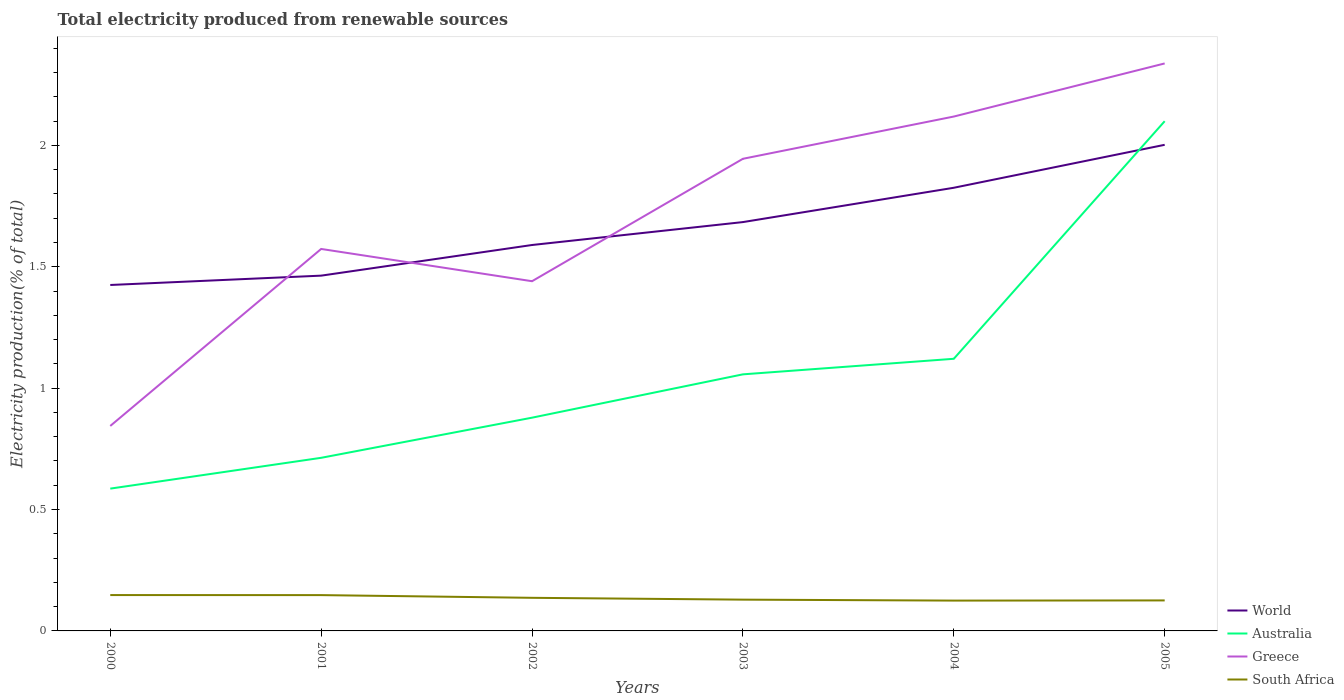Is the number of lines equal to the number of legend labels?
Provide a succinct answer. Yes. Across all years, what is the maximum total electricity produced in South Africa?
Ensure brevity in your answer.  0.12. What is the total total electricity produced in South Africa in the graph?
Make the answer very short. 0.01. What is the difference between the highest and the second highest total electricity produced in Australia?
Make the answer very short. 1.51. How many lines are there?
Give a very brief answer. 4. What is the difference between two consecutive major ticks on the Y-axis?
Keep it short and to the point. 0.5. Are the values on the major ticks of Y-axis written in scientific E-notation?
Your answer should be very brief. No. Does the graph contain any zero values?
Ensure brevity in your answer.  No. Where does the legend appear in the graph?
Keep it short and to the point. Bottom right. How many legend labels are there?
Make the answer very short. 4. What is the title of the graph?
Ensure brevity in your answer.  Total electricity produced from renewable sources. What is the label or title of the X-axis?
Offer a very short reply. Years. What is the label or title of the Y-axis?
Ensure brevity in your answer.  Electricity production(% of total). What is the Electricity production(% of total) in World in 2000?
Ensure brevity in your answer.  1.42. What is the Electricity production(% of total) in Australia in 2000?
Ensure brevity in your answer.  0.59. What is the Electricity production(% of total) in Greece in 2000?
Offer a very short reply. 0.84. What is the Electricity production(% of total) in South Africa in 2000?
Provide a short and direct response. 0.15. What is the Electricity production(% of total) in World in 2001?
Give a very brief answer. 1.46. What is the Electricity production(% of total) in Australia in 2001?
Offer a terse response. 0.71. What is the Electricity production(% of total) of Greece in 2001?
Offer a terse response. 1.57. What is the Electricity production(% of total) in South Africa in 2001?
Provide a succinct answer. 0.15. What is the Electricity production(% of total) in World in 2002?
Give a very brief answer. 1.59. What is the Electricity production(% of total) in Australia in 2002?
Offer a very short reply. 0.88. What is the Electricity production(% of total) of Greece in 2002?
Provide a short and direct response. 1.44. What is the Electricity production(% of total) in South Africa in 2002?
Provide a short and direct response. 0.14. What is the Electricity production(% of total) in World in 2003?
Your answer should be compact. 1.68. What is the Electricity production(% of total) of Australia in 2003?
Give a very brief answer. 1.06. What is the Electricity production(% of total) of Greece in 2003?
Keep it short and to the point. 1.94. What is the Electricity production(% of total) in South Africa in 2003?
Provide a succinct answer. 0.13. What is the Electricity production(% of total) in World in 2004?
Offer a very short reply. 1.83. What is the Electricity production(% of total) in Australia in 2004?
Your answer should be compact. 1.12. What is the Electricity production(% of total) in Greece in 2004?
Offer a terse response. 2.12. What is the Electricity production(% of total) in South Africa in 2004?
Make the answer very short. 0.12. What is the Electricity production(% of total) in World in 2005?
Your answer should be compact. 2. What is the Electricity production(% of total) of Australia in 2005?
Provide a succinct answer. 2.1. What is the Electricity production(% of total) of Greece in 2005?
Give a very brief answer. 2.34. What is the Electricity production(% of total) in South Africa in 2005?
Your response must be concise. 0.13. Across all years, what is the maximum Electricity production(% of total) of World?
Ensure brevity in your answer.  2. Across all years, what is the maximum Electricity production(% of total) in Australia?
Provide a short and direct response. 2.1. Across all years, what is the maximum Electricity production(% of total) of Greece?
Keep it short and to the point. 2.34. Across all years, what is the maximum Electricity production(% of total) in South Africa?
Offer a terse response. 0.15. Across all years, what is the minimum Electricity production(% of total) in World?
Provide a succinct answer. 1.42. Across all years, what is the minimum Electricity production(% of total) of Australia?
Ensure brevity in your answer.  0.59. Across all years, what is the minimum Electricity production(% of total) of Greece?
Your response must be concise. 0.84. Across all years, what is the minimum Electricity production(% of total) of South Africa?
Give a very brief answer. 0.12. What is the total Electricity production(% of total) of World in the graph?
Make the answer very short. 9.99. What is the total Electricity production(% of total) in Australia in the graph?
Offer a very short reply. 6.45. What is the total Electricity production(% of total) in Greece in the graph?
Your response must be concise. 10.26. What is the total Electricity production(% of total) in South Africa in the graph?
Give a very brief answer. 0.81. What is the difference between the Electricity production(% of total) of World in 2000 and that in 2001?
Your response must be concise. -0.04. What is the difference between the Electricity production(% of total) of Australia in 2000 and that in 2001?
Your answer should be very brief. -0.13. What is the difference between the Electricity production(% of total) in Greece in 2000 and that in 2001?
Offer a very short reply. -0.73. What is the difference between the Electricity production(% of total) of South Africa in 2000 and that in 2001?
Offer a very short reply. 0. What is the difference between the Electricity production(% of total) of World in 2000 and that in 2002?
Offer a terse response. -0.16. What is the difference between the Electricity production(% of total) of Australia in 2000 and that in 2002?
Provide a short and direct response. -0.29. What is the difference between the Electricity production(% of total) in Greece in 2000 and that in 2002?
Your answer should be very brief. -0.6. What is the difference between the Electricity production(% of total) in South Africa in 2000 and that in 2002?
Your answer should be very brief. 0.01. What is the difference between the Electricity production(% of total) in World in 2000 and that in 2003?
Offer a terse response. -0.26. What is the difference between the Electricity production(% of total) in Australia in 2000 and that in 2003?
Give a very brief answer. -0.47. What is the difference between the Electricity production(% of total) of Greece in 2000 and that in 2003?
Provide a short and direct response. -1.1. What is the difference between the Electricity production(% of total) in South Africa in 2000 and that in 2003?
Offer a very short reply. 0.02. What is the difference between the Electricity production(% of total) of World in 2000 and that in 2004?
Ensure brevity in your answer.  -0.4. What is the difference between the Electricity production(% of total) of Australia in 2000 and that in 2004?
Keep it short and to the point. -0.53. What is the difference between the Electricity production(% of total) of Greece in 2000 and that in 2004?
Provide a succinct answer. -1.27. What is the difference between the Electricity production(% of total) in South Africa in 2000 and that in 2004?
Your response must be concise. 0.02. What is the difference between the Electricity production(% of total) in World in 2000 and that in 2005?
Offer a terse response. -0.58. What is the difference between the Electricity production(% of total) of Australia in 2000 and that in 2005?
Offer a very short reply. -1.51. What is the difference between the Electricity production(% of total) in Greece in 2000 and that in 2005?
Your answer should be very brief. -1.49. What is the difference between the Electricity production(% of total) of South Africa in 2000 and that in 2005?
Give a very brief answer. 0.02. What is the difference between the Electricity production(% of total) of World in 2001 and that in 2002?
Give a very brief answer. -0.13. What is the difference between the Electricity production(% of total) in Australia in 2001 and that in 2002?
Ensure brevity in your answer.  -0.17. What is the difference between the Electricity production(% of total) in Greece in 2001 and that in 2002?
Keep it short and to the point. 0.13. What is the difference between the Electricity production(% of total) in South Africa in 2001 and that in 2002?
Your answer should be compact. 0.01. What is the difference between the Electricity production(% of total) of World in 2001 and that in 2003?
Ensure brevity in your answer.  -0.22. What is the difference between the Electricity production(% of total) in Australia in 2001 and that in 2003?
Offer a terse response. -0.34. What is the difference between the Electricity production(% of total) in Greece in 2001 and that in 2003?
Your answer should be compact. -0.37. What is the difference between the Electricity production(% of total) in South Africa in 2001 and that in 2003?
Provide a succinct answer. 0.02. What is the difference between the Electricity production(% of total) in World in 2001 and that in 2004?
Your answer should be compact. -0.36. What is the difference between the Electricity production(% of total) of Australia in 2001 and that in 2004?
Your answer should be very brief. -0.41. What is the difference between the Electricity production(% of total) of Greece in 2001 and that in 2004?
Your response must be concise. -0.55. What is the difference between the Electricity production(% of total) in South Africa in 2001 and that in 2004?
Make the answer very short. 0.02. What is the difference between the Electricity production(% of total) of World in 2001 and that in 2005?
Provide a succinct answer. -0.54. What is the difference between the Electricity production(% of total) in Australia in 2001 and that in 2005?
Offer a terse response. -1.39. What is the difference between the Electricity production(% of total) of Greece in 2001 and that in 2005?
Your response must be concise. -0.76. What is the difference between the Electricity production(% of total) in South Africa in 2001 and that in 2005?
Your response must be concise. 0.02. What is the difference between the Electricity production(% of total) of World in 2002 and that in 2003?
Make the answer very short. -0.09. What is the difference between the Electricity production(% of total) in Australia in 2002 and that in 2003?
Offer a very short reply. -0.18. What is the difference between the Electricity production(% of total) of Greece in 2002 and that in 2003?
Make the answer very short. -0.5. What is the difference between the Electricity production(% of total) of South Africa in 2002 and that in 2003?
Give a very brief answer. 0.01. What is the difference between the Electricity production(% of total) of World in 2002 and that in 2004?
Your answer should be very brief. -0.24. What is the difference between the Electricity production(% of total) in Australia in 2002 and that in 2004?
Offer a terse response. -0.24. What is the difference between the Electricity production(% of total) of Greece in 2002 and that in 2004?
Offer a terse response. -0.68. What is the difference between the Electricity production(% of total) of South Africa in 2002 and that in 2004?
Your answer should be very brief. 0.01. What is the difference between the Electricity production(% of total) in World in 2002 and that in 2005?
Provide a succinct answer. -0.41. What is the difference between the Electricity production(% of total) of Australia in 2002 and that in 2005?
Provide a succinct answer. -1.22. What is the difference between the Electricity production(% of total) in Greece in 2002 and that in 2005?
Make the answer very short. -0.9. What is the difference between the Electricity production(% of total) of South Africa in 2002 and that in 2005?
Your answer should be very brief. 0.01. What is the difference between the Electricity production(% of total) in World in 2003 and that in 2004?
Your answer should be compact. -0.14. What is the difference between the Electricity production(% of total) of Australia in 2003 and that in 2004?
Offer a terse response. -0.06. What is the difference between the Electricity production(% of total) of Greece in 2003 and that in 2004?
Keep it short and to the point. -0.17. What is the difference between the Electricity production(% of total) in South Africa in 2003 and that in 2004?
Provide a short and direct response. 0. What is the difference between the Electricity production(% of total) of World in 2003 and that in 2005?
Offer a terse response. -0.32. What is the difference between the Electricity production(% of total) of Australia in 2003 and that in 2005?
Offer a terse response. -1.04. What is the difference between the Electricity production(% of total) of Greece in 2003 and that in 2005?
Ensure brevity in your answer.  -0.39. What is the difference between the Electricity production(% of total) in South Africa in 2003 and that in 2005?
Give a very brief answer. 0. What is the difference between the Electricity production(% of total) of World in 2004 and that in 2005?
Your answer should be compact. -0.18. What is the difference between the Electricity production(% of total) in Australia in 2004 and that in 2005?
Keep it short and to the point. -0.98. What is the difference between the Electricity production(% of total) in Greece in 2004 and that in 2005?
Ensure brevity in your answer.  -0.22. What is the difference between the Electricity production(% of total) in South Africa in 2004 and that in 2005?
Your answer should be very brief. -0. What is the difference between the Electricity production(% of total) of World in 2000 and the Electricity production(% of total) of Australia in 2001?
Offer a terse response. 0.71. What is the difference between the Electricity production(% of total) in World in 2000 and the Electricity production(% of total) in Greece in 2001?
Provide a succinct answer. -0.15. What is the difference between the Electricity production(% of total) of World in 2000 and the Electricity production(% of total) of South Africa in 2001?
Offer a very short reply. 1.28. What is the difference between the Electricity production(% of total) of Australia in 2000 and the Electricity production(% of total) of Greece in 2001?
Offer a terse response. -0.99. What is the difference between the Electricity production(% of total) in Australia in 2000 and the Electricity production(% of total) in South Africa in 2001?
Ensure brevity in your answer.  0.44. What is the difference between the Electricity production(% of total) in Greece in 2000 and the Electricity production(% of total) in South Africa in 2001?
Offer a very short reply. 0.7. What is the difference between the Electricity production(% of total) of World in 2000 and the Electricity production(% of total) of Australia in 2002?
Ensure brevity in your answer.  0.55. What is the difference between the Electricity production(% of total) in World in 2000 and the Electricity production(% of total) in Greece in 2002?
Keep it short and to the point. -0.02. What is the difference between the Electricity production(% of total) of World in 2000 and the Electricity production(% of total) of South Africa in 2002?
Keep it short and to the point. 1.29. What is the difference between the Electricity production(% of total) of Australia in 2000 and the Electricity production(% of total) of Greece in 2002?
Provide a succinct answer. -0.85. What is the difference between the Electricity production(% of total) of Australia in 2000 and the Electricity production(% of total) of South Africa in 2002?
Your response must be concise. 0.45. What is the difference between the Electricity production(% of total) in Greece in 2000 and the Electricity production(% of total) in South Africa in 2002?
Offer a terse response. 0.71. What is the difference between the Electricity production(% of total) of World in 2000 and the Electricity production(% of total) of Australia in 2003?
Keep it short and to the point. 0.37. What is the difference between the Electricity production(% of total) of World in 2000 and the Electricity production(% of total) of Greece in 2003?
Offer a terse response. -0.52. What is the difference between the Electricity production(% of total) in World in 2000 and the Electricity production(% of total) in South Africa in 2003?
Make the answer very short. 1.3. What is the difference between the Electricity production(% of total) in Australia in 2000 and the Electricity production(% of total) in Greece in 2003?
Make the answer very short. -1.36. What is the difference between the Electricity production(% of total) in Australia in 2000 and the Electricity production(% of total) in South Africa in 2003?
Keep it short and to the point. 0.46. What is the difference between the Electricity production(% of total) of Greece in 2000 and the Electricity production(% of total) of South Africa in 2003?
Provide a short and direct response. 0.72. What is the difference between the Electricity production(% of total) of World in 2000 and the Electricity production(% of total) of Australia in 2004?
Give a very brief answer. 0.3. What is the difference between the Electricity production(% of total) of World in 2000 and the Electricity production(% of total) of Greece in 2004?
Provide a short and direct response. -0.69. What is the difference between the Electricity production(% of total) in World in 2000 and the Electricity production(% of total) in South Africa in 2004?
Make the answer very short. 1.3. What is the difference between the Electricity production(% of total) of Australia in 2000 and the Electricity production(% of total) of Greece in 2004?
Provide a short and direct response. -1.53. What is the difference between the Electricity production(% of total) of Australia in 2000 and the Electricity production(% of total) of South Africa in 2004?
Give a very brief answer. 0.46. What is the difference between the Electricity production(% of total) in Greece in 2000 and the Electricity production(% of total) in South Africa in 2004?
Offer a very short reply. 0.72. What is the difference between the Electricity production(% of total) in World in 2000 and the Electricity production(% of total) in Australia in 2005?
Provide a succinct answer. -0.67. What is the difference between the Electricity production(% of total) of World in 2000 and the Electricity production(% of total) of Greece in 2005?
Keep it short and to the point. -0.91. What is the difference between the Electricity production(% of total) in World in 2000 and the Electricity production(% of total) in South Africa in 2005?
Offer a terse response. 1.3. What is the difference between the Electricity production(% of total) of Australia in 2000 and the Electricity production(% of total) of Greece in 2005?
Keep it short and to the point. -1.75. What is the difference between the Electricity production(% of total) in Australia in 2000 and the Electricity production(% of total) in South Africa in 2005?
Your answer should be very brief. 0.46. What is the difference between the Electricity production(% of total) of Greece in 2000 and the Electricity production(% of total) of South Africa in 2005?
Provide a short and direct response. 0.72. What is the difference between the Electricity production(% of total) in World in 2001 and the Electricity production(% of total) in Australia in 2002?
Your response must be concise. 0.58. What is the difference between the Electricity production(% of total) in World in 2001 and the Electricity production(% of total) in Greece in 2002?
Provide a succinct answer. 0.02. What is the difference between the Electricity production(% of total) of World in 2001 and the Electricity production(% of total) of South Africa in 2002?
Keep it short and to the point. 1.33. What is the difference between the Electricity production(% of total) of Australia in 2001 and the Electricity production(% of total) of Greece in 2002?
Make the answer very short. -0.73. What is the difference between the Electricity production(% of total) of Australia in 2001 and the Electricity production(% of total) of South Africa in 2002?
Offer a very short reply. 0.58. What is the difference between the Electricity production(% of total) in Greece in 2001 and the Electricity production(% of total) in South Africa in 2002?
Provide a short and direct response. 1.44. What is the difference between the Electricity production(% of total) in World in 2001 and the Electricity production(% of total) in Australia in 2003?
Your response must be concise. 0.41. What is the difference between the Electricity production(% of total) in World in 2001 and the Electricity production(% of total) in Greece in 2003?
Your answer should be very brief. -0.48. What is the difference between the Electricity production(% of total) of World in 2001 and the Electricity production(% of total) of South Africa in 2003?
Keep it short and to the point. 1.33. What is the difference between the Electricity production(% of total) of Australia in 2001 and the Electricity production(% of total) of Greece in 2003?
Your answer should be compact. -1.23. What is the difference between the Electricity production(% of total) in Australia in 2001 and the Electricity production(% of total) in South Africa in 2003?
Offer a terse response. 0.58. What is the difference between the Electricity production(% of total) in Greece in 2001 and the Electricity production(% of total) in South Africa in 2003?
Give a very brief answer. 1.44. What is the difference between the Electricity production(% of total) of World in 2001 and the Electricity production(% of total) of Australia in 2004?
Your response must be concise. 0.34. What is the difference between the Electricity production(% of total) of World in 2001 and the Electricity production(% of total) of Greece in 2004?
Provide a short and direct response. -0.66. What is the difference between the Electricity production(% of total) in World in 2001 and the Electricity production(% of total) in South Africa in 2004?
Your response must be concise. 1.34. What is the difference between the Electricity production(% of total) of Australia in 2001 and the Electricity production(% of total) of Greece in 2004?
Keep it short and to the point. -1.41. What is the difference between the Electricity production(% of total) of Australia in 2001 and the Electricity production(% of total) of South Africa in 2004?
Your answer should be compact. 0.59. What is the difference between the Electricity production(% of total) in Greece in 2001 and the Electricity production(% of total) in South Africa in 2004?
Offer a very short reply. 1.45. What is the difference between the Electricity production(% of total) of World in 2001 and the Electricity production(% of total) of Australia in 2005?
Give a very brief answer. -0.64. What is the difference between the Electricity production(% of total) of World in 2001 and the Electricity production(% of total) of Greece in 2005?
Offer a very short reply. -0.87. What is the difference between the Electricity production(% of total) in World in 2001 and the Electricity production(% of total) in South Africa in 2005?
Offer a very short reply. 1.34. What is the difference between the Electricity production(% of total) in Australia in 2001 and the Electricity production(% of total) in Greece in 2005?
Offer a very short reply. -1.62. What is the difference between the Electricity production(% of total) in Australia in 2001 and the Electricity production(% of total) in South Africa in 2005?
Your response must be concise. 0.59. What is the difference between the Electricity production(% of total) in Greece in 2001 and the Electricity production(% of total) in South Africa in 2005?
Provide a short and direct response. 1.45. What is the difference between the Electricity production(% of total) of World in 2002 and the Electricity production(% of total) of Australia in 2003?
Your response must be concise. 0.53. What is the difference between the Electricity production(% of total) in World in 2002 and the Electricity production(% of total) in Greece in 2003?
Keep it short and to the point. -0.36. What is the difference between the Electricity production(% of total) of World in 2002 and the Electricity production(% of total) of South Africa in 2003?
Keep it short and to the point. 1.46. What is the difference between the Electricity production(% of total) of Australia in 2002 and the Electricity production(% of total) of Greece in 2003?
Keep it short and to the point. -1.07. What is the difference between the Electricity production(% of total) of Australia in 2002 and the Electricity production(% of total) of South Africa in 2003?
Provide a succinct answer. 0.75. What is the difference between the Electricity production(% of total) of Greece in 2002 and the Electricity production(% of total) of South Africa in 2003?
Provide a succinct answer. 1.31. What is the difference between the Electricity production(% of total) in World in 2002 and the Electricity production(% of total) in Australia in 2004?
Offer a very short reply. 0.47. What is the difference between the Electricity production(% of total) of World in 2002 and the Electricity production(% of total) of Greece in 2004?
Ensure brevity in your answer.  -0.53. What is the difference between the Electricity production(% of total) of World in 2002 and the Electricity production(% of total) of South Africa in 2004?
Provide a succinct answer. 1.46. What is the difference between the Electricity production(% of total) of Australia in 2002 and the Electricity production(% of total) of Greece in 2004?
Your answer should be very brief. -1.24. What is the difference between the Electricity production(% of total) of Australia in 2002 and the Electricity production(% of total) of South Africa in 2004?
Offer a terse response. 0.75. What is the difference between the Electricity production(% of total) in Greece in 2002 and the Electricity production(% of total) in South Africa in 2004?
Offer a very short reply. 1.32. What is the difference between the Electricity production(% of total) of World in 2002 and the Electricity production(% of total) of Australia in 2005?
Give a very brief answer. -0.51. What is the difference between the Electricity production(% of total) in World in 2002 and the Electricity production(% of total) in Greece in 2005?
Provide a short and direct response. -0.75. What is the difference between the Electricity production(% of total) in World in 2002 and the Electricity production(% of total) in South Africa in 2005?
Your answer should be very brief. 1.46. What is the difference between the Electricity production(% of total) in Australia in 2002 and the Electricity production(% of total) in Greece in 2005?
Your answer should be compact. -1.46. What is the difference between the Electricity production(% of total) in Australia in 2002 and the Electricity production(% of total) in South Africa in 2005?
Your answer should be very brief. 0.75. What is the difference between the Electricity production(% of total) in Greece in 2002 and the Electricity production(% of total) in South Africa in 2005?
Make the answer very short. 1.31. What is the difference between the Electricity production(% of total) in World in 2003 and the Electricity production(% of total) in Australia in 2004?
Your answer should be compact. 0.56. What is the difference between the Electricity production(% of total) of World in 2003 and the Electricity production(% of total) of Greece in 2004?
Provide a short and direct response. -0.43. What is the difference between the Electricity production(% of total) in World in 2003 and the Electricity production(% of total) in South Africa in 2004?
Provide a succinct answer. 1.56. What is the difference between the Electricity production(% of total) of Australia in 2003 and the Electricity production(% of total) of Greece in 2004?
Ensure brevity in your answer.  -1.06. What is the difference between the Electricity production(% of total) of Australia in 2003 and the Electricity production(% of total) of South Africa in 2004?
Offer a very short reply. 0.93. What is the difference between the Electricity production(% of total) of Greece in 2003 and the Electricity production(% of total) of South Africa in 2004?
Ensure brevity in your answer.  1.82. What is the difference between the Electricity production(% of total) of World in 2003 and the Electricity production(% of total) of Australia in 2005?
Your answer should be compact. -0.42. What is the difference between the Electricity production(% of total) in World in 2003 and the Electricity production(% of total) in Greece in 2005?
Provide a short and direct response. -0.65. What is the difference between the Electricity production(% of total) of World in 2003 and the Electricity production(% of total) of South Africa in 2005?
Ensure brevity in your answer.  1.56. What is the difference between the Electricity production(% of total) of Australia in 2003 and the Electricity production(% of total) of Greece in 2005?
Your answer should be very brief. -1.28. What is the difference between the Electricity production(% of total) of Australia in 2003 and the Electricity production(% of total) of South Africa in 2005?
Your answer should be very brief. 0.93. What is the difference between the Electricity production(% of total) of Greece in 2003 and the Electricity production(% of total) of South Africa in 2005?
Your response must be concise. 1.82. What is the difference between the Electricity production(% of total) of World in 2004 and the Electricity production(% of total) of Australia in 2005?
Your answer should be compact. -0.27. What is the difference between the Electricity production(% of total) of World in 2004 and the Electricity production(% of total) of Greece in 2005?
Your answer should be compact. -0.51. What is the difference between the Electricity production(% of total) in World in 2004 and the Electricity production(% of total) in South Africa in 2005?
Your answer should be compact. 1.7. What is the difference between the Electricity production(% of total) of Australia in 2004 and the Electricity production(% of total) of Greece in 2005?
Offer a terse response. -1.22. What is the difference between the Electricity production(% of total) in Greece in 2004 and the Electricity production(% of total) in South Africa in 2005?
Offer a terse response. 1.99. What is the average Electricity production(% of total) in World per year?
Your response must be concise. 1.66. What is the average Electricity production(% of total) of Australia per year?
Give a very brief answer. 1.08. What is the average Electricity production(% of total) of Greece per year?
Your response must be concise. 1.71. What is the average Electricity production(% of total) in South Africa per year?
Keep it short and to the point. 0.14. In the year 2000, what is the difference between the Electricity production(% of total) of World and Electricity production(% of total) of Australia?
Offer a very short reply. 0.84. In the year 2000, what is the difference between the Electricity production(% of total) in World and Electricity production(% of total) in Greece?
Give a very brief answer. 0.58. In the year 2000, what is the difference between the Electricity production(% of total) in World and Electricity production(% of total) in South Africa?
Your answer should be very brief. 1.28. In the year 2000, what is the difference between the Electricity production(% of total) in Australia and Electricity production(% of total) in Greece?
Provide a succinct answer. -0.26. In the year 2000, what is the difference between the Electricity production(% of total) in Australia and Electricity production(% of total) in South Africa?
Give a very brief answer. 0.44. In the year 2000, what is the difference between the Electricity production(% of total) of Greece and Electricity production(% of total) of South Africa?
Provide a succinct answer. 0.7. In the year 2001, what is the difference between the Electricity production(% of total) of World and Electricity production(% of total) of Australia?
Offer a terse response. 0.75. In the year 2001, what is the difference between the Electricity production(% of total) in World and Electricity production(% of total) in Greece?
Keep it short and to the point. -0.11. In the year 2001, what is the difference between the Electricity production(% of total) in World and Electricity production(% of total) in South Africa?
Offer a terse response. 1.32. In the year 2001, what is the difference between the Electricity production(% of total) in Australia and Electricity production(% of total) in Greece?
Make the answer very short. -0.86. In the year 2001, what is the difference between the Electricity production(% of total) of Australia and Electricity production(% of total) of South Africa?
Keep it short and to the point. 0.57. In the year 2001, what is the difference between the Electricity production(% of total) of Greece and Electricity production(% of total) of South Africa?
Give a very brief answer. 1.43. In the year 2002, what is the difference between the Electricity production(% of total) of World and Electricity production(% of total) of Australia?
Your answer should be very brief. 0.71. In the year 2002, what is the difference between the Electricity production(% of total) in World and Electricity production(% of total) in Greece?
Offer a very short reply. 0.15. In the year 2002, what is the difference between the Electricity production(% of total) in World and Electricity production(% of total) in South Africa?
Your answer should be very brief. 1.45. In the year 2002, what is the difference between the Electricity production(% of total) of Australia and Electricity production(% of total) of Greece?
Your response must be concise. -0.56. In the year 2002, what is the difference between the Electricity production(% of total) in Australia and Electricity production(% of total) in South Africa?
Provide a succinct answer. 0.74. In the year 2002, what is the difference between the Electricity production(% of total) in Greece and Electricity production(% of total) in South Africa?
Ensure brevity in your answer.  1.3. In the year 2003, what is the difference between the Electricity production(% of total) of World and Electricity production(% of total) of Australia?
Make the answer very short. 0.63. In the year 2003, what is the difference between the Electricity production(% of total) of World and Electricity production(% of total) of Greece?
Your answer should be compact. -0.26. In the year 2003, what is the difference between the Electricity production(% of total) of World and Electricity production(% of total) of South Africa?
Provide a succinct answer. 1.55. In the year 2003, what is the difference between the Electricity production(% of total) in Australia and Electricity production(% of total) in Greece?
Your answer should be compact. -0.89. In the year 2003, what is the difference between the Electricity production(% of total) of Australia and Electricity production(% of total) of South Africa?
Give a very brief answer. 0.93. In the year 2003, what is the difference between the Electricity production(% of total) of Greece and Electricity production(% of total) of South Africa?
Make the answer very short. 1.82. In the year 2004, what is the difference between the Electricity production(% of total) in World and Electricity production(% of total) in Australia?
Offer a terse response. 0.7. In the year 2004, what is the difference between the Electricity production(% of total) of World and Electricity production(% of total) of Greece?
Offer a terse response. -0.29. In the year 2004, what is the difference between the Electricity production(% of total) in World and Electricity production(% of total) in South Africa?
Keep it short and to the point. 1.7. In the year 2004, what is the difference between the Electricity production(% of total) in Australia and Electricity production(% of total) in Greece?
Provide a short and direct response. -1. In the year 2004, what is the difference between the Electricity production(% of total) of Australia and Electricity production(% of total) of South Africa?
Offer a very short reply. 1. In the year 2004, what is the difference between the Electricity production(% of total) of Greece and Electricity production(% of total) of South Africa?
Ensure brevity in your answer.  1.99. In the year 2005, what is the difference between the Electricity production(% of total) of World and Electricity production(% of total) of Australia?
Keep it short and to the point. -0.1. In the year 2005, what is the difference between the Electricity production(% of total) of World and Electricity production(% of total) of Greece?
Your answer should be very brief. -0.34. In the year 2005, what is the difference between the Electricity production(% of total) in World and Electricity production(% of total) in South Africa?
Ensure brevity in your answer.  1.88. In the year 2005, what is the difference between the Electricity production(% of total) of Australia and Electricity production(% of total) of Greece?
Your response must be concise. -0.24. In the year 2005, what is the difference between the Electricity production(% of total) of Australia and Electricity production(% of total) of South Africa?
Your response must be concise. 1.97. In the year 2005, what is the difference between the Electricity production(% of total) of Greece and Electricity production(% of total) of South Africa?
Make the answer very short. 2.21. What is the ratio of the Electricity production(% of total) of World in 2000 to that in 2001?
Ensure brevity in your answer.  0.97. What is the ratio of the Electricity production(% of total) in Australia in 2000 to that in 2001?
Provide a succinct answer. 0.82. What is the ratio of the Electricity production(% of total) of Greece in 2000 to that in 2001?
Your answer should be compact. 0.54. What is the ratio of the Electricity production(% of total) in South Africa in 2000 to that in 2001?
Offer a very short reply. 1. What is the ratio of the Electricity production(% of total) of World in 2000 to that in 2002?
Ensure brevity in your answer.  0.9. What is the ratio of the Electricity production(% of total) of Australia in 2000 to that in 2002?
Give a very brief answer. 0.67. What is the ratio of the Electricity production(% of total) in Greece in 2000 to that in 2002?
Provide a succinct answer. 0.59. What is the ratio of the Electricity production(% of total) in South Africa in 2000 to that in 2002?
Offer a very short reply. 1.08. What is the ratio of the Electricity production(% of total) in World in 2000 to that in 2003?
Your answer should be compact. 0.85. What is the ratio of the Electricity production(% of total) in Australia in 2000 to that in 2003?
Provide a succinct answer. 0.55. What is the ratio of the Electricity production(% of total) of Greece in 2000 to that in 2003?
Your response must be concise. 0.43. What is the ratio of the Electricity production(% of total) of South Africa in 2000 to that in 2003?
Offer a very short reply. 1.15. What is the ratio of the Electricity production(% of total) of World in 2000 to that in 2004?
Offer a very short reply. 0.78. What is the ratio of the Electricity production(% of total) in Australia in 2000 to that in 2004?
Make the answer very short. 0.52. What is the ratio of the Electricity production(% of total) of Greece in 2000 to that in 2004?
Your answer should be very brief. 0.4. What is the ratio of the Electricity production(% of total) of South Africa in 2000 to that in 2004?
Your answer should be very brief. 1.18. What is the ratio of the Electricity production(% of total) of World in 2000 to that in 2005?
Your answer should be very brief. 0.71. What is the ratio of the Electricity production(% of total) of Australia in 2000 to that in 2005?
Your answer should be compact. 0.28. What is the ratio of the Electricity production(% of total) of Greece in 2000 to that in 2005?
Your answer should be very brief. 0.36. What is the ratio of the Electricity production(% of total) in South Africa in 2000 to that in 2005?
Your answer should be compact. 1.18. What is the ratio of the Electricity production(% of total) of World in 2001 to that in 2002?
Make the answer very short. 0.92. What is the ratio of the Electricity production(% of total) of Australia in 2001 to that in 2002?
Provide a short and direct response. 0.81. What is the ratio of the Electricity production(% of total) in Greece in 2001 to that in 2002?
Provide a short and direct response. 1.09. What is the ratio of the Electricity production(% of total) in South Africa in 2001 to that in 2002?
Give a very brief answer. 1.08. What is the ratio of the Electricity production(% of total) in World in 2001 to that in 2003?
Keep it short and to the point. 0.87. What is the ratio of the Electricity production(% of total) in Australia in 2001 to that in 2003?
Make the answer very short. 0.67. What is the ratio of the Electricity production(% of total) in Greece in 2001 to that in 2003?
Provide a short and direct response. 0.81. What is the ratio of the Electricity production(% of total) in South Africa in 2001 to that in 2003?
Your answer should be compact. 1.14. What is the ratio of the Electricity production(% of total) of World in 2001 to that in 2004?
Your answer should be very brief. 0.8. What is the ratio of the Electricity production(% of total) in Australia in 2001 to that in 2004?
Provide a succinct answer. 0.64. What is the ratio of the Electricity production(% of total) of Greece in 2001 to that in 2004?
Provide a succinct answer. 0.74. What is the ratio of the Electricity production(% of total) of South Africa in 2001 to that in 2004?
Give a very brief answer. 1.18. What is the ratio of the Electricity production(% of total) of World in 2001 to that in 2005?
Offer a terse response. 0.73. What is the ratio of the Electricity production(% of total) of Australia in 2001 to that in 2005?
Ensure brevity in your answer.  0.34. What is the ratio of the Electricity production(% of total) of Greece in 2001 to that in 2005?
Your answer should be compact. 0.67. What is the ratio of the Electricity production(% of total) in South Africa in 2001 to that in 2005?
Your response must be concise. 1.17. What is the ratio of the Electricity production(% of total) of World in 2002 to that in 2003?
Ensure brevity in your answer.  0.94. What is the ratio of the Electricity production(% of total) of Australia in 2002 to that in 2003?
Ensure brevity in your answer.  0.83. What is the ratio of the Electricity production(% of total) in Greece in 2002 to that in 2003?
Give a very brief answer. 0.74. What is the ratio of the Electricity production(% of total) in South Africa in 2002 to that in 2003?
Offer a very short reply. 1.06. What is the ratio of the Electricity production(% of total) of World in 2002 to that in 2004?
Offer a very short reply. 0.87. What is the ratio of the Electricity production(% of total) of Australia in 2002 to that in 2004?
Keep it short and to the point. 0.78. What is the ratio of the Electricity production(% of total) in Greece in 2002 to that in 2004?
Keep it short and to the point. 0.68. What is the ratio of the Electricity production(% of total) in South Africa in 2002 to that in 2004?
Ensure brevity in your answer.  1.09. What is the ratio of the Electricity production(% of total) in World in 2002 to that in 2005?
Make the answer very short. 0.79. What is the ratio of the Electricity production(% of total) of Australia in 2002 to that in 2005?
Your answer should be very brief. 0.42. What is the ratio of the Electricity production(% of total) of Greece in 2002 to that in 2005?
Your answer should be compact. 0.62. What is the ratio of the Electricity production(% of total) of South Africa in 2002 to that in 2005?
Your answer should be very brief. 1.09. What is the ratio of the Electricity production(% of total) of World in 2003 to that in 2004?
Your response must be concise. 0.92. What is the ratio of the Electricity production(% of total) in Australia in 2003 to that in 2004?
Provide a short and direct response. 0.94. What is the ratio of the Electricity production(% of total) of Greece in 2003 to that in 2004?
Provide a succinct answer. 0.92. What is the ratio of the Electricity production(% of total) of South Africa in 2003 to that in 2004?
Make the answer very short. 1.03. What is the ratio of the Electricity production(% of total) in World in 2003 to that in 2005?
Make the answer very short. 0.84. What is the ratio of the Electricity production(% of total) in Australia in 2003 to that in 2005?
Keep it short and to the point. 0.5. What is the ratio of the Electricity production(% of total) of Greece in 2003 to that in 2005?
Ensure brevity in your answer.  0.83. What is the ratio of the Electricity production(% of total) in South Africa in 2003 to that in 2005?
Your response must be concise. 1.03. What is the ratio of the Electricity production(% of total) of World in 2004 to that in 2005?
Your answer should be very brief. 0.91. What is the ratio of the Electricity production(% of total) in Australia in 2004 to that in 2005?
Your response must be concise. 0.53. What is the ratio of the Electricity production(% of total) in Greece in 2004 to that in 2005?
Provide a succinct answer. 0.91. What is the ratio of the Electricity production(% of total) of South Africa in 2004 to that in 2005?
Your response must be concise. 0.99. What is the difference between the highest and the second highest Electricity production(% of total) in World?
Keep it short and to the point. 0.18. What is the difference between the highest and the second highest Electricity production(% of total) of Australia?
Your answer should be compact. 0.98. What is the difference between the highest and the second highest Electricity production(% of total) of Greece?
Offer a terse response. 0.22. What is the difference between the highest and the lowest Electricity production(% of total) in World?
Give a very brief answer. 0.58. What is the difference between the highest and the lowest Electricity production(% of total) in Australia?
Provide a succinct answer. 1.51. What is the difference between the highest and the lowest Electricity production(% of total) of Greece?
Your answer should be very brief. 1.49. What is the difference between the highest and the lowest Electricity production(% of total) in South Africa?
Your answer should be very brief. 0.02. 